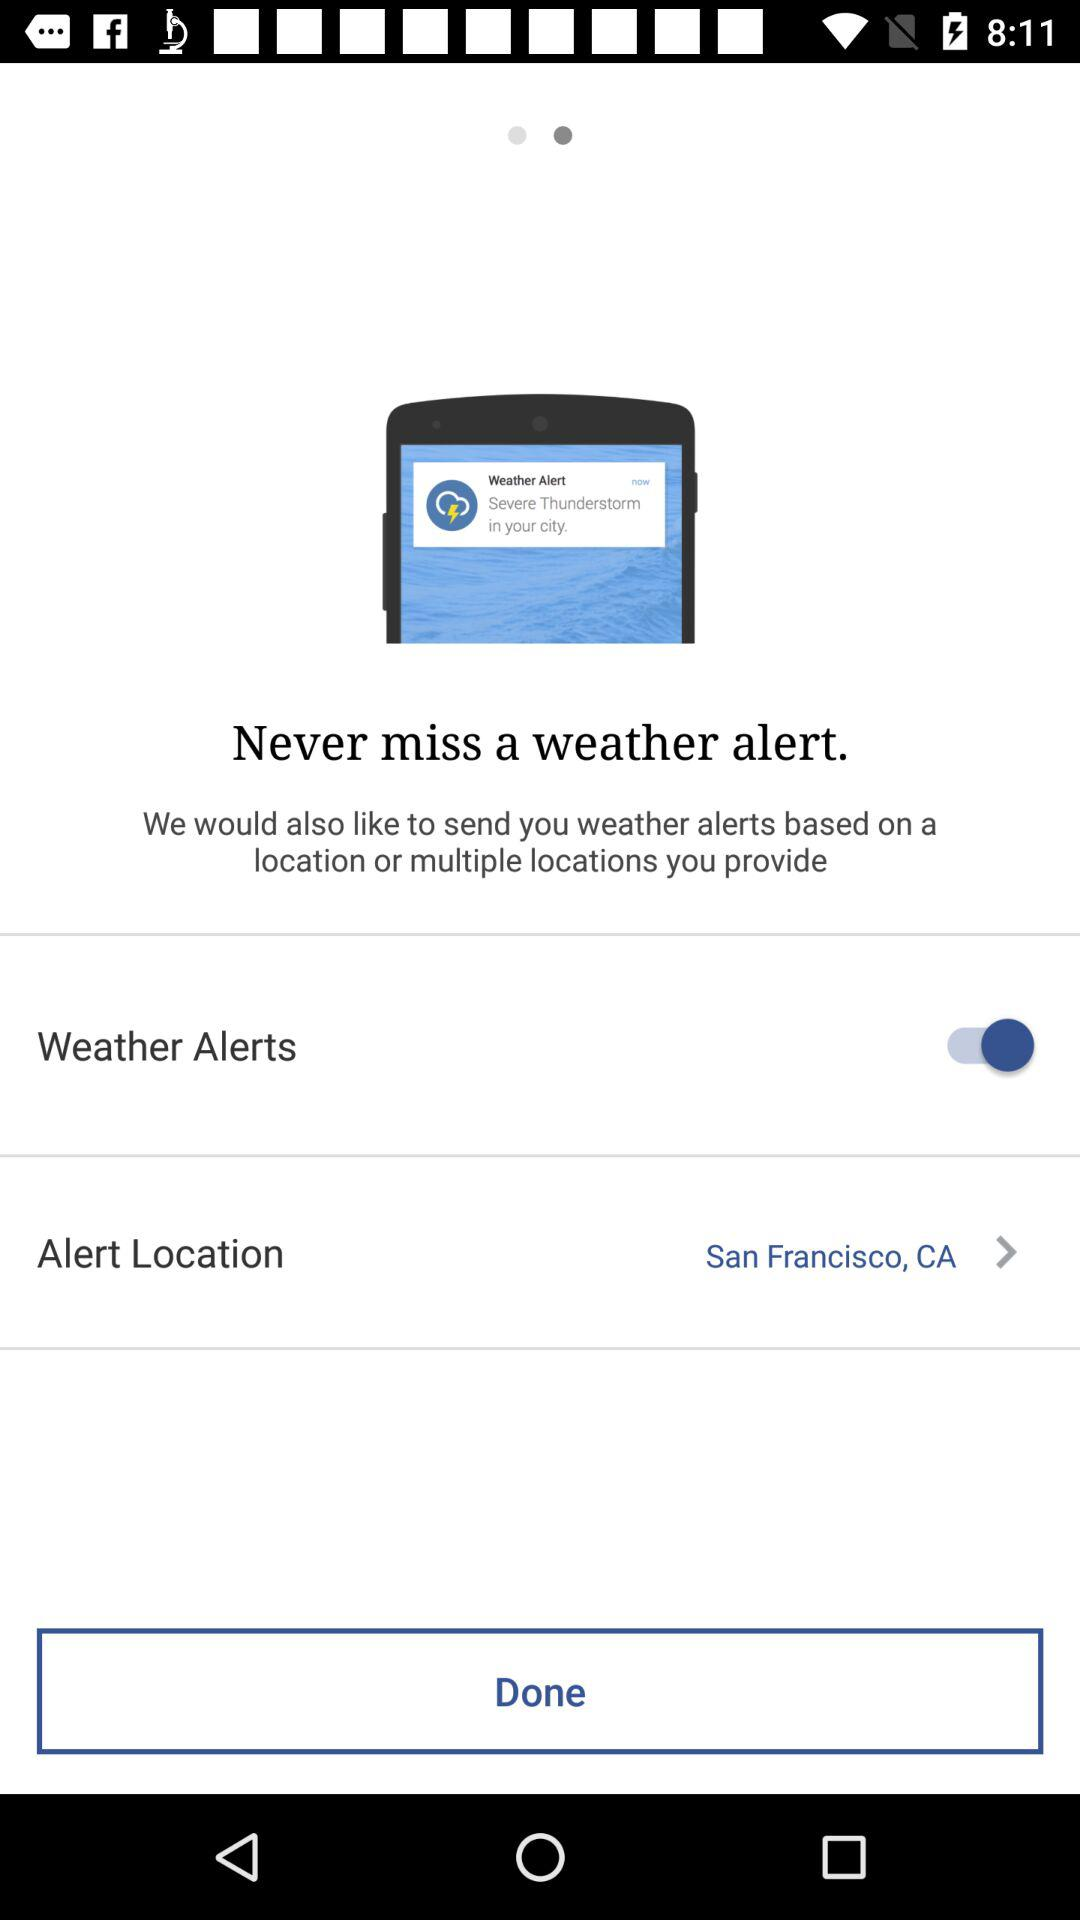Which devices will alerts be sent to?
When the provided information is insufficient, respond with <no answer>. <no answer> 